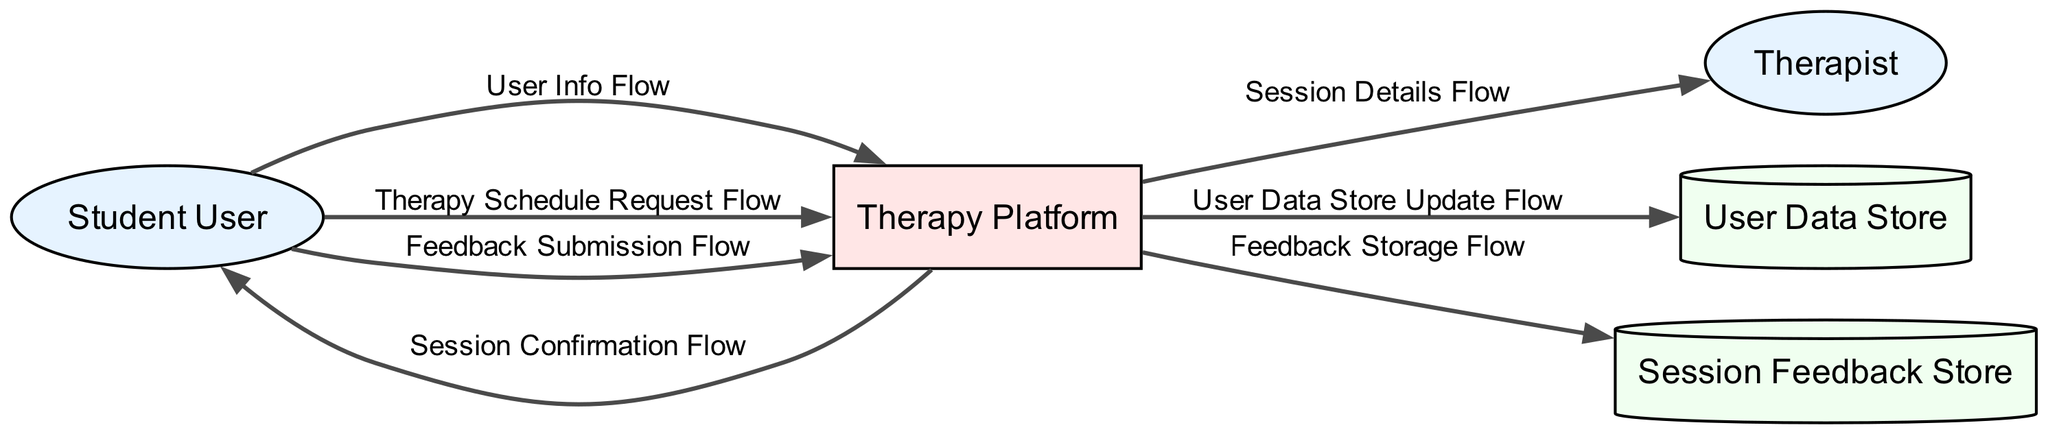What is the total number of entities depicted in the diagram? The diagram lists three entities: Student User, Therapist, and Therapy Platform. Thus, the total number is three.
Answer: 3 What type of data does the User Data Store contain? The User Data Store contains user profile information, preferences, and history of therapy sessions, as described in the diagram.
Answer: User profile information, preferences, and history of therapy sessions Which flow originates from the Student User and leads to the Therapy Platform? The flows "User Info Flow" and "Therapy Schedule Request Flow" both originate from the Student User and lead to the Therapy Platform, as indicated in the diagram.
Answer: User Info Flow and Therapy Schedule Request Flow How many feedback flows are present in the diagram? There are two feedback-related flows: "Feedback Submission Flow," which comes from the Student User to the Therapy Platform, and "Feedback Storage Flow," which goes from the Therapy Platform to the Session Feedback Store.
Answer: 2 What information is transferred in the Session Details Flow? The Session Details Flow transfers scheduled session details, including the time, user's background information, and specific issues to address, according to the diagram.
Answer: Scheduled session details including time, user's background information, and specific issues to address Which data store is updated with session history from the Therapy Platform? The User Data Store is updated with session history and notes from the therapist through the "User Data Store Update Flow" as stated in the diagram.
Answer: User Data Store What is the final destination of the Feedback Storage Flow? The final destination of the Feedback Storage Flow is the Session Feedback Store, as shown in the diagram.
Answer: Session Feedback Store What is the primary function of the Therapy Platform as depicted in the diagram? The primary function of the Therapy Platform is to facilitate the therapy sessions, including scheduling sessions and collecting feedback, as described in its entity description.
Answer: Facilitate therapy sessions including scheduling and collecting feedback 